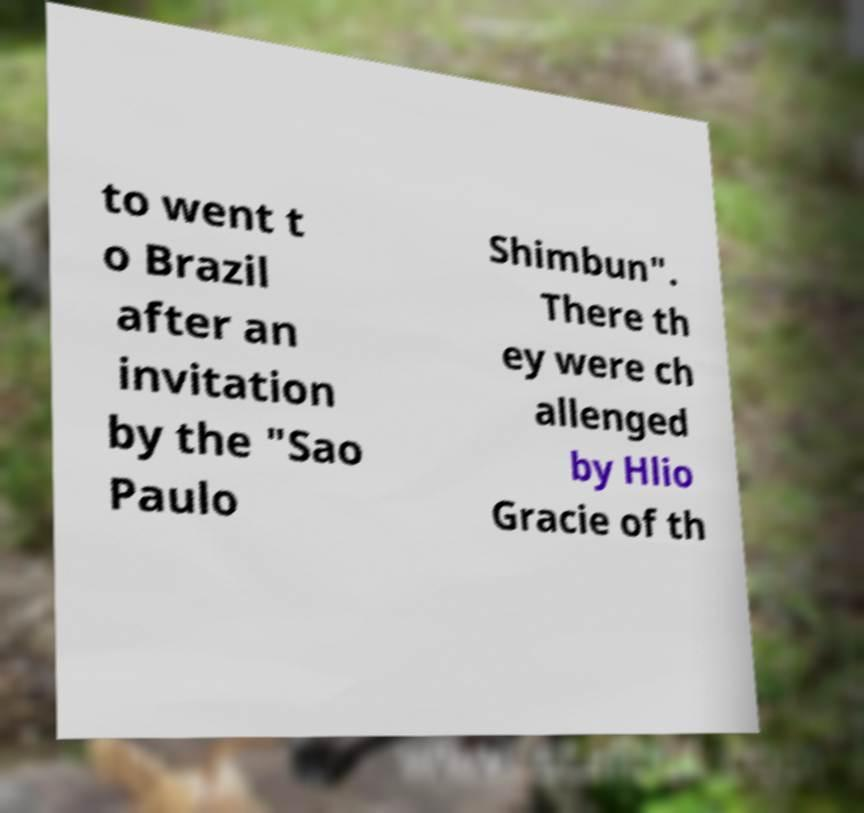Could you extract and type out the text from this image? to went t o Brazil after an invitation by the "Sao Paulo Shimbun". There th ey were ch allenged by Hlio Gracie of th 